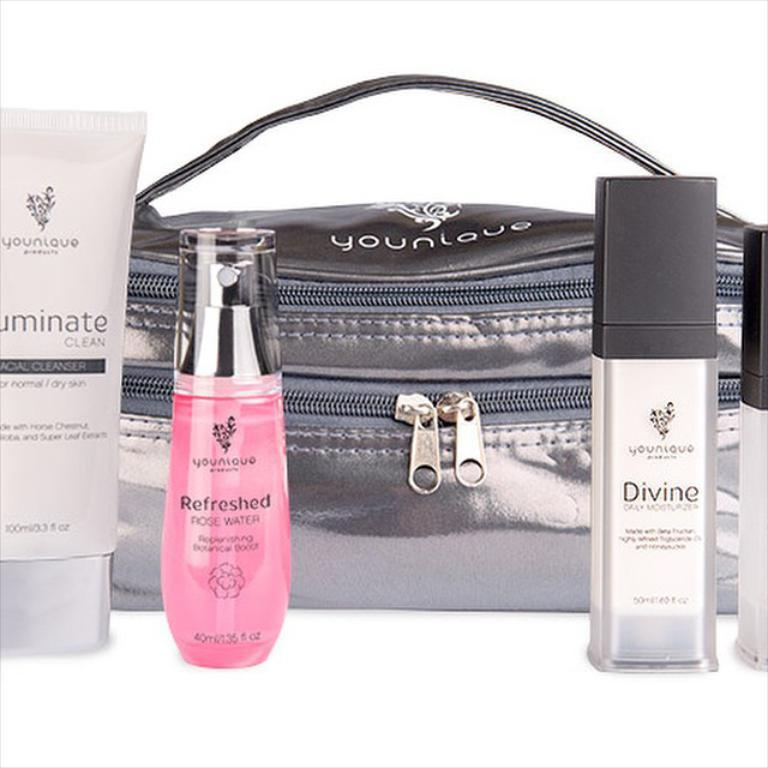<image>
Relay a brief, clear account of the picture shown. A bottle to the right has divine on the front in black letters. 